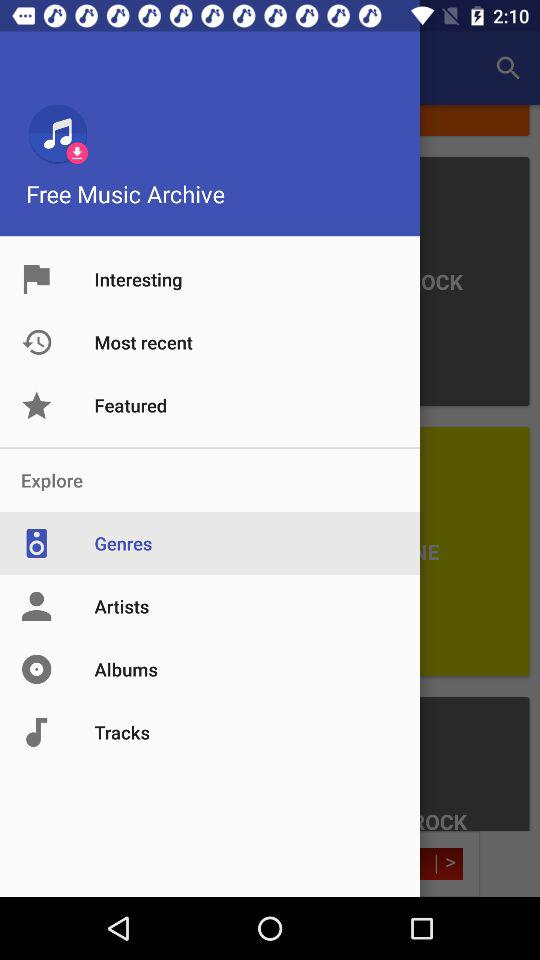Which is the selected item in the menu? The selected item is "Genres". 